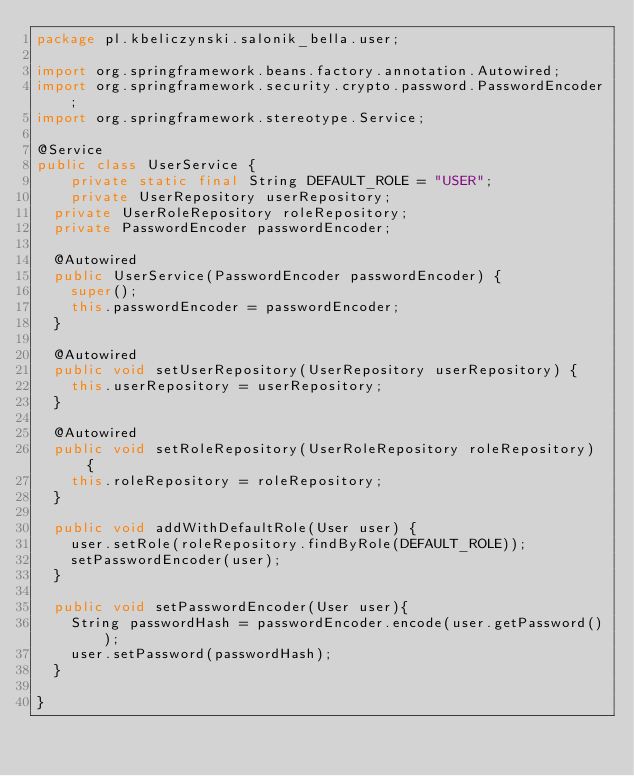<code> <loc_0><loc_0><loc_500><loc_500><_Java_>package pl.kbeliczynski.salonik_bella.user;

import org.springframework.beans.factory.annotation.Autowired;
import org.springframework.security.crypto.password.PasswordEncoder;
import org.springframework.stereotype.Service;

@Service
public class UserService {
    private static final String DEFAULT_ROLE = "USER";
    private UserRepository userRepository;
	private UserRoleRepository roleRepository;
	private PasswordEncoder passwordEncoder;

	@Autowired
	public UserService(PasswordEncoder passwordEncoder) {
		super();
		this.passwordEncoder = passwordEncoder;
	}

	@Autowired
	public void setUserRepository(UserRepository userRepository) {
		this.userRepository = userRepository;
	}

	@Autowired
	public void setRoleRepository(UserRoleRepository roleRepository) {
		this.roleRepository = roleRepository;
	}

	public void addWithDefaultRole(User user) {
		user.setRole(roleRepository.findByRole(DEFAULT_ROLE));
		setPasswordEncoder(user);
	}

	public void setPasswordEncoder(User user){
		String passwordHash = passwordEncoder.encode(user.getPassword());
		user.setPassword(passwordHash);
	}

}
</code> 